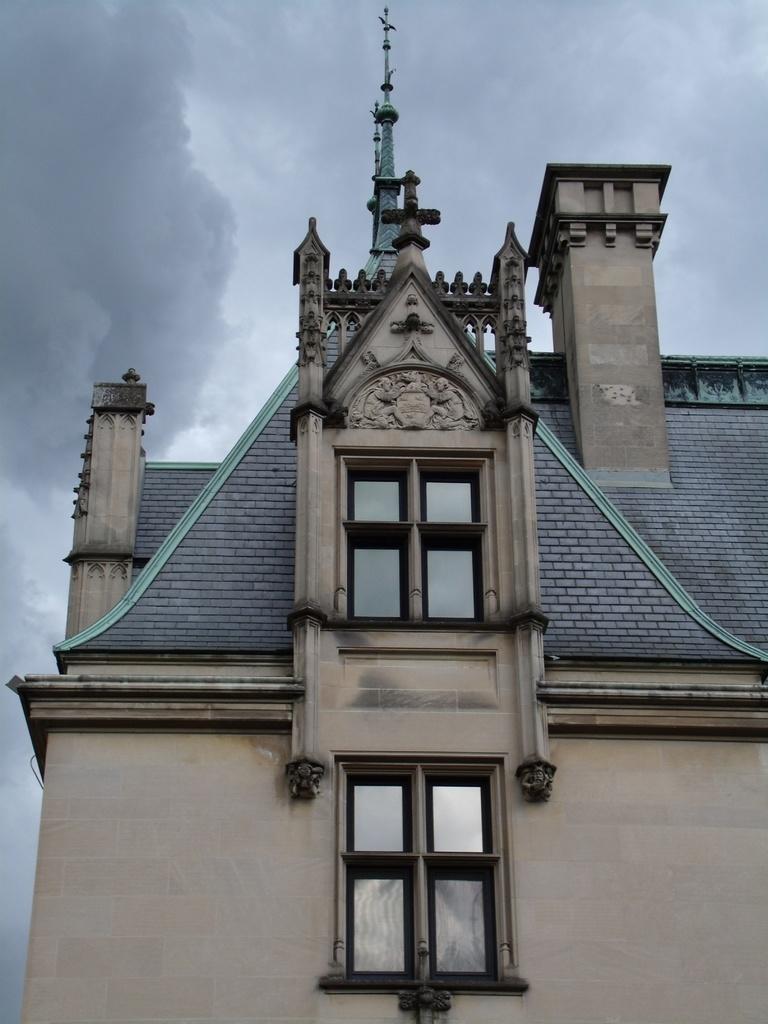Could you give a brief overview of what you see in this image? In this picture we can see statues on the wall and windows, top of the building we can see poles. In the background of the image we can see sky with clouds. 